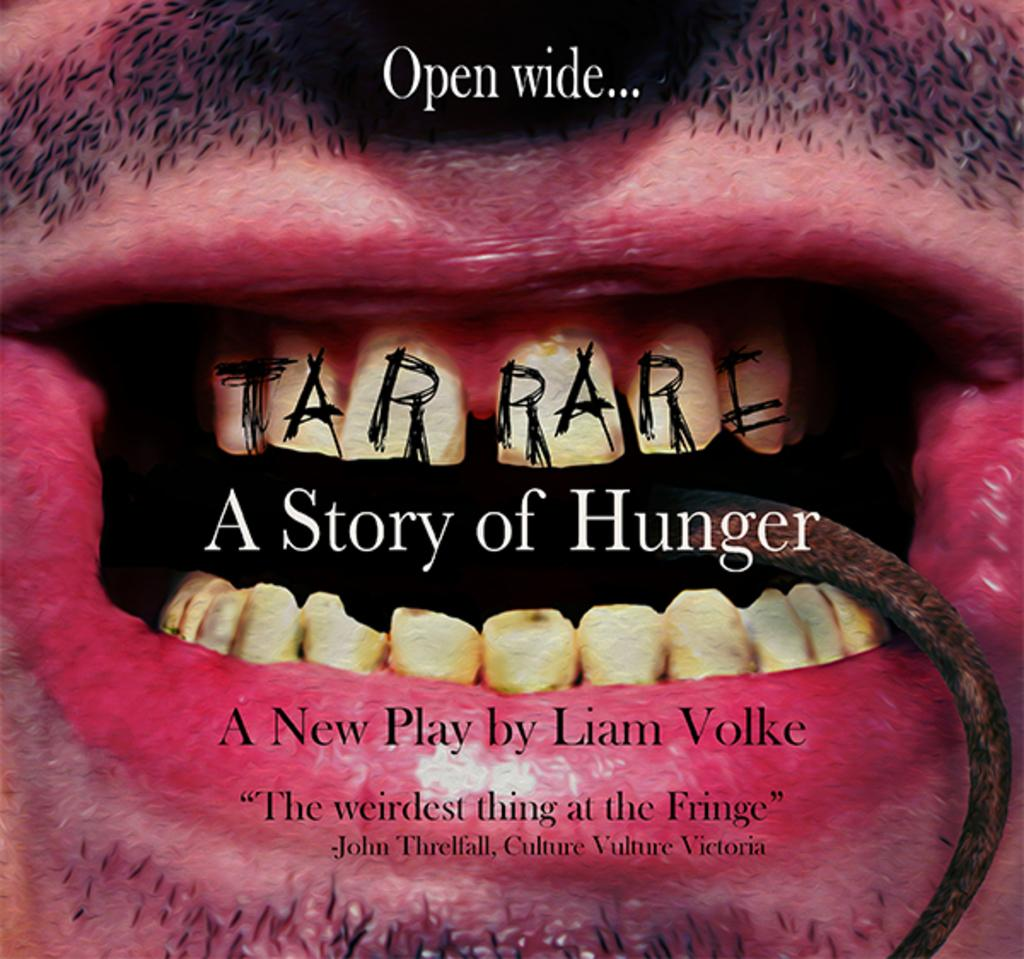What is present in the image? There is a person in the image. What part of the person's face is visible? The person's mouth and teeth are visible. Is there any text or writing on the person's mouth or teeth? Yes, there is something written on the person's mouth or teeth. What type of crown is the fireman wearing in the image? There is no fireman or crown present in the image. How many steps can be seen leading up to the person in the image? There is no reference to steps in the image, so it is not possible to determine how many steps might be present. 